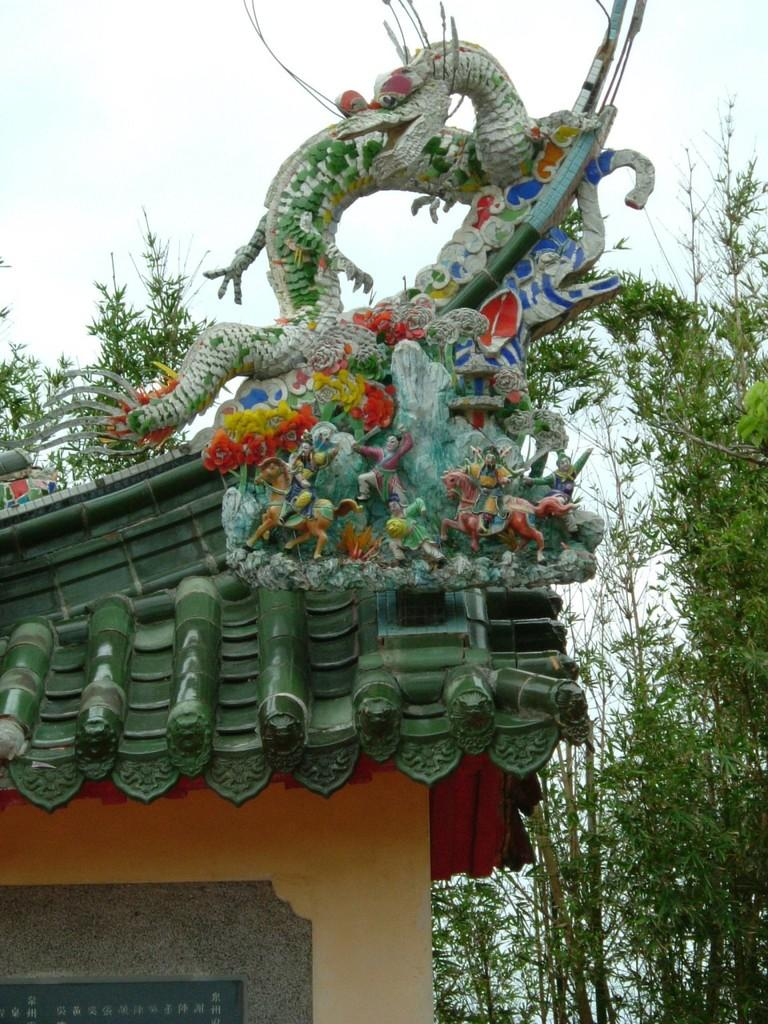What can be seen on the roof in the image? There is a sculpture on the roof in the image. What type of vegetation is on the right side of the image? There are trees on the right side of the image. What is visible in the background of the image? The sky is visible in the background of the image. How does the sculpture limit the amount of breath one can take in the image? The sculpture does not limit the amount of breath one can take in the image, as it is a stationary object and not related to breathing. 